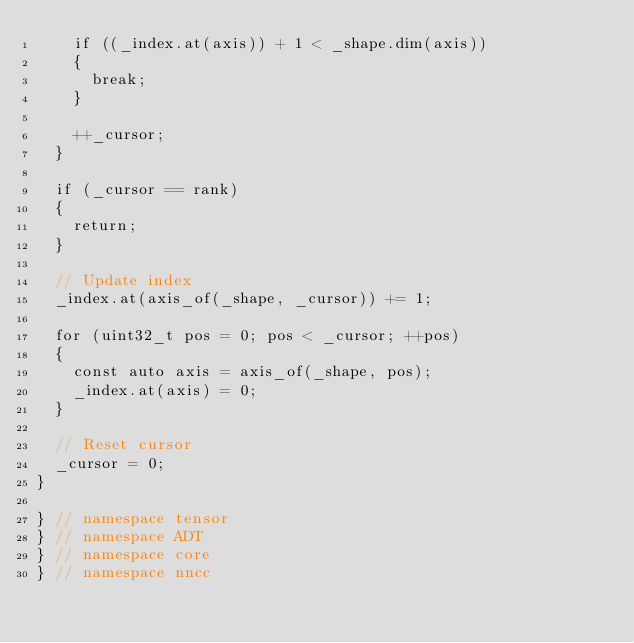<code> <loc_0><loc_0><loc_500><loc_500><_C++_>    if ((_index.at(axis)) + 1 < _shape.dim(axis))
    {
      break;
    }

    ++_cursor;
  }

  if (_cursor == rank)
  {
    return;
  }

  // Update index
  _index.at(axis_of(_shape, _cursor)) += 1;

  for (uint32_t pos = 0; pos < _cursor; ++pos)
  {
    const auto axis = axis_of(_shape, pos);
    _index.at(axis) = 0;
  }

  // Reset cursor
  _cursor = 0;
}

} // namespace tensor
} // namespace ADT
} // namespace core
} // namespace nncc
</code> 